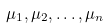<formula> <loc_0><loc_0><loc_500><loc_500>\mu _ { 1 } , \mu _ { 2 } , \dots , \mu _ { n }</formula> 